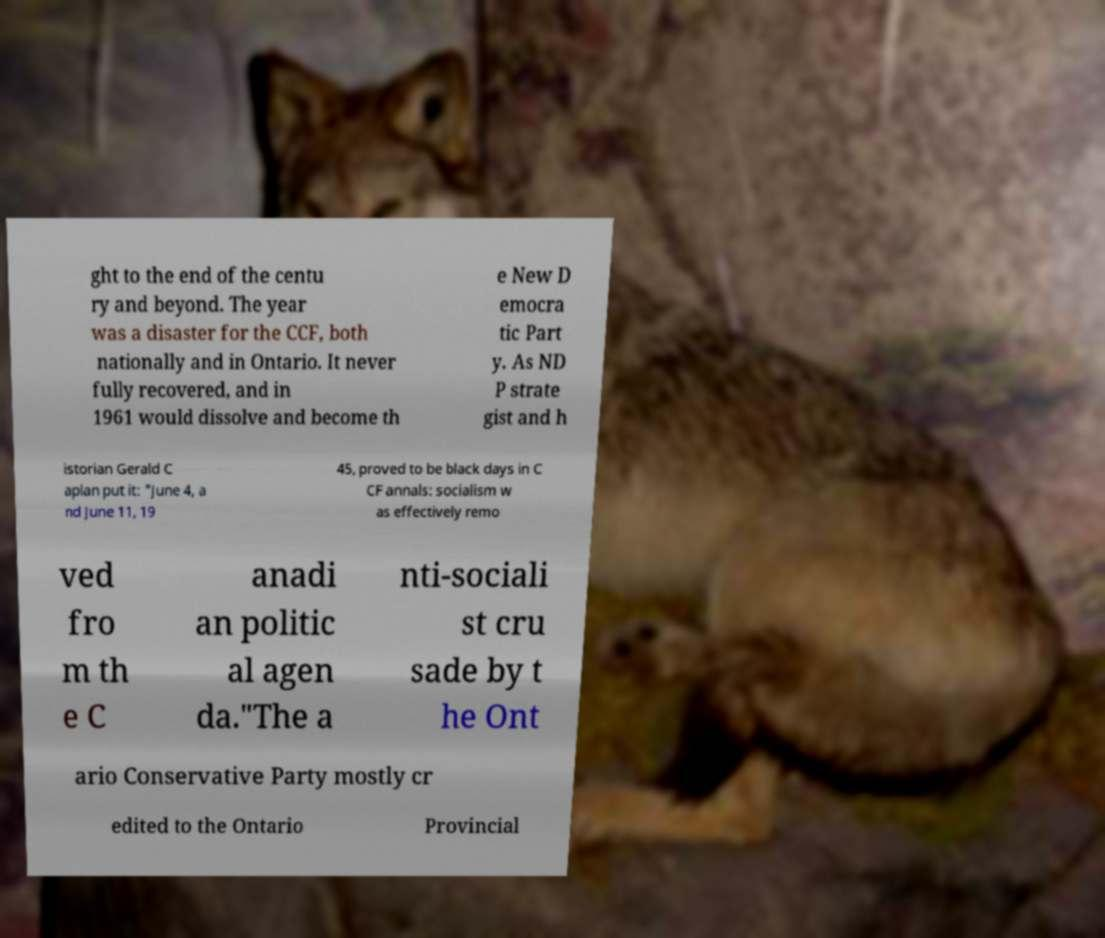Please identify and transcribe the text found in this image. ght to the end of the centu ry and beyond. The year was a disaster for the CCF, both nationally and in Ontario. It never fully recovered, and in 1961 would dissolve and become th e New D emocra tic Part y. As ND P strate gist and h istorian Gerald C aplan put it: "June 4, a nd June 11, 19 45, proved to be black days in C CF annals: socialism w as effectively remo ved fro m th e C anadi an politic al agen da."The a nti-sociali st cru sade by t he Ont ario Conservative Party mostly cr edited to the Ontario Provincial 